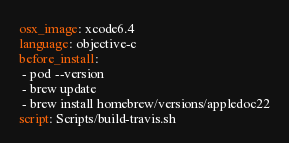<code> <loc_0><loc_0><loc_500><loc_500><_YAML_>osx_image: xcode6.4
language: objective-c
before_install: 
 - pod --version
 - brew update
 - brew install homebrew/versions/appledoc22
script: Scripts/build-travis.sh
</code> 